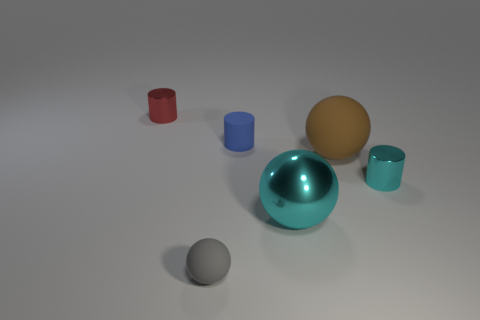There is another thing that is the same color as the large metallic thing; what is its material? The other object sharing the same glossy teal color as the large metallic sphere appears to be a small cup or container, which is also likely to be made of metal, given its reflective surface and similarity in appearance. 